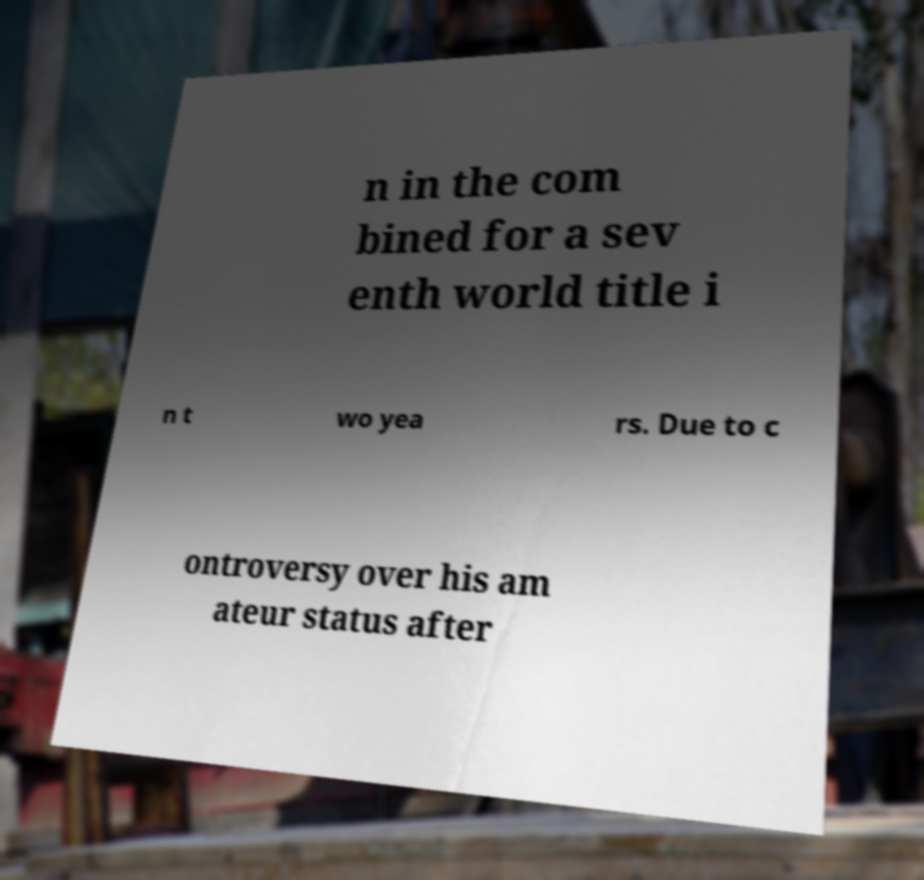Can you accurately transcribe the text from the provided image for me? n in the com bined for a sev enth world title i n t wo yea rs. Due to c ontroversy over his am ateur status after 